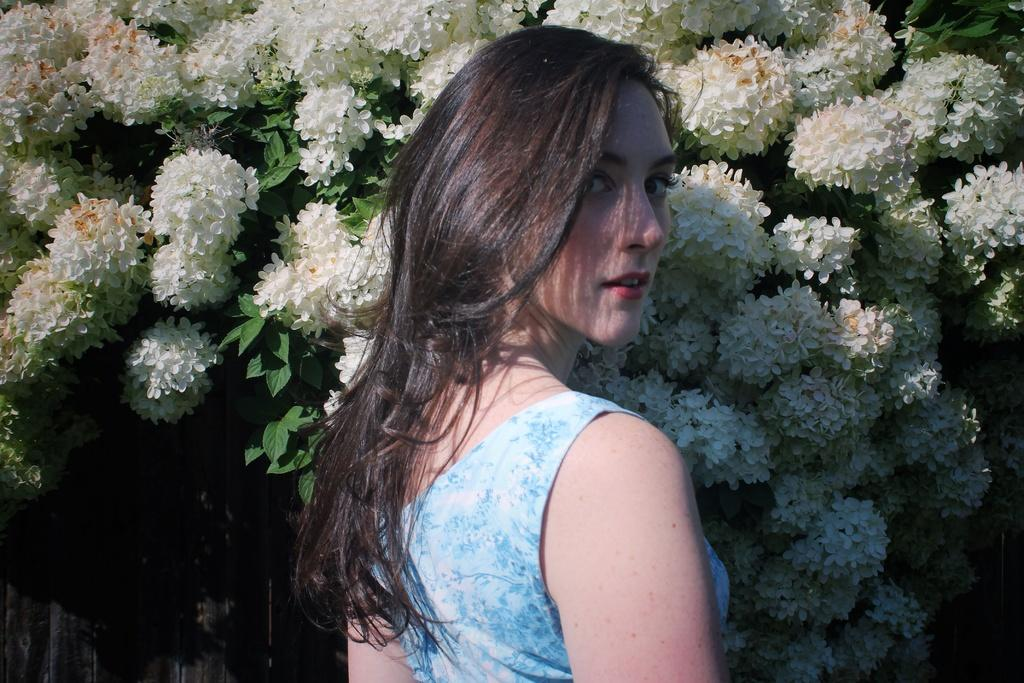Who is present in the image? There is a woman in the image. What is the woman wearing? The woman is wearing a blue dress. What is the woman's expression in the image? The woman is smiling. What type of flowers can be seen in the image? There are white flowers in the image. What is the source of the flowers? The flowers are from a tree. What is the color of the tree's leaves? The tree has green leaves. What unit of time is the woman measuring in the image? There is no indication in the image that the woman is measuring any unit of time. 